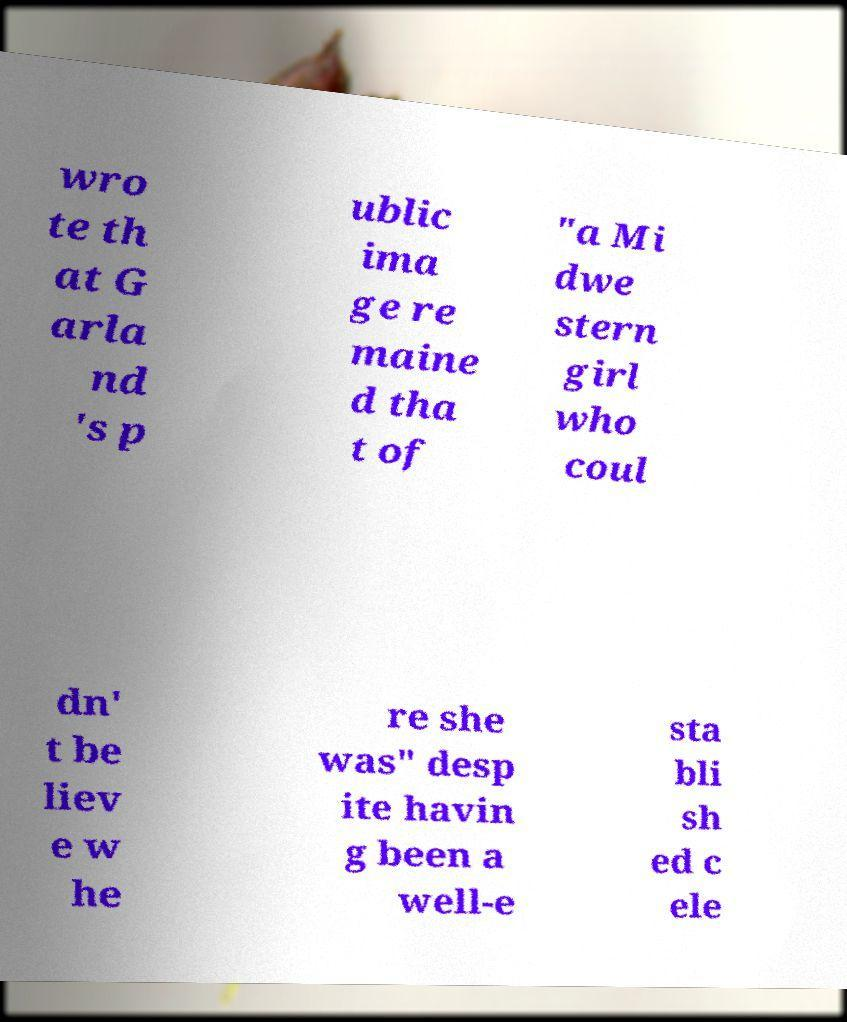Could you extract and type out the text from this image? wro te th at G arla nd 's p ublic ima ge re maine d tha t of "a Mi dwe stern girl who coul dn' t be liev e w he re she was" desp ite havin g been a well-e sta bli sh ed c ele 